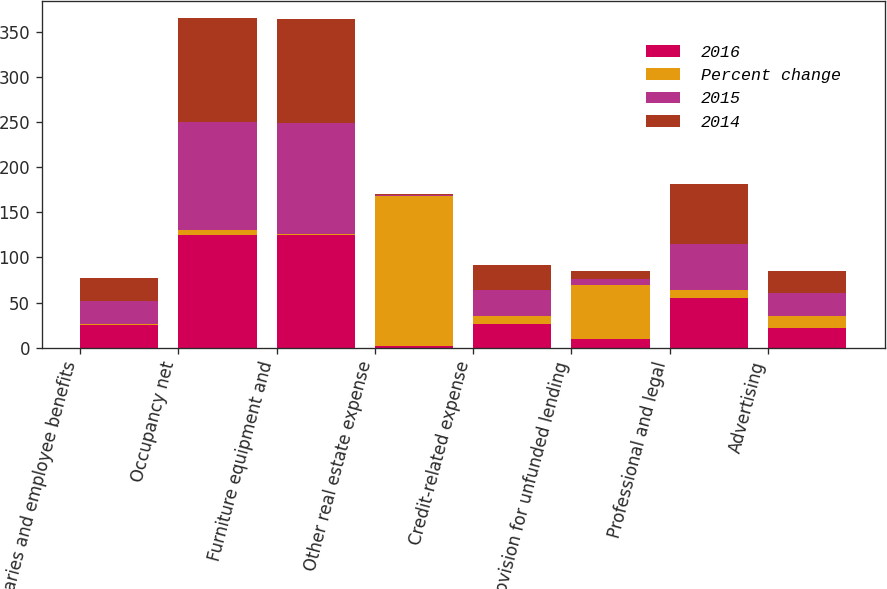Convert chart to OTSL. <chart><loc_0><loc_0><loc_500><loc_500><stacked_bar_chart><ecel><fcel>Salaries and employee benefits<fcel>Occupancy net<fcel>Furniture equipment and<fcel>Other real estate expense<fcel>Credit-related expense<fcel>Provision for unfunded lending<fcel>Professional and legal<fcel>Advertising<nl><fcel>2016<fcel>25.3<fcel>125.3<fcel>124.7<fcel>1.6<fcel>25.7<fcel>9.9<fcel>55.1<fcel>22.1<nl><fcel>Percent change<fcel>1<fcel>4.9<fcel>1.2<fcel>166.7<fcel>9.8<fcel>59.7<fcel>9.3<fcel>12.6<nl><fcel>2015<fcel>25.3<fcel>119.5<fcel>123.2<fcel>0.6<fcel>28.5<fcel>6.2<fcel>50.4<fcel>25.3<nl><fcel>2014<fcel>25.3<fcel>115.7<fcel>115.3<fcel>1.2<fcel>28.1<fcel>8.6<fcel>66<fcel>25.1<nl></chart> 